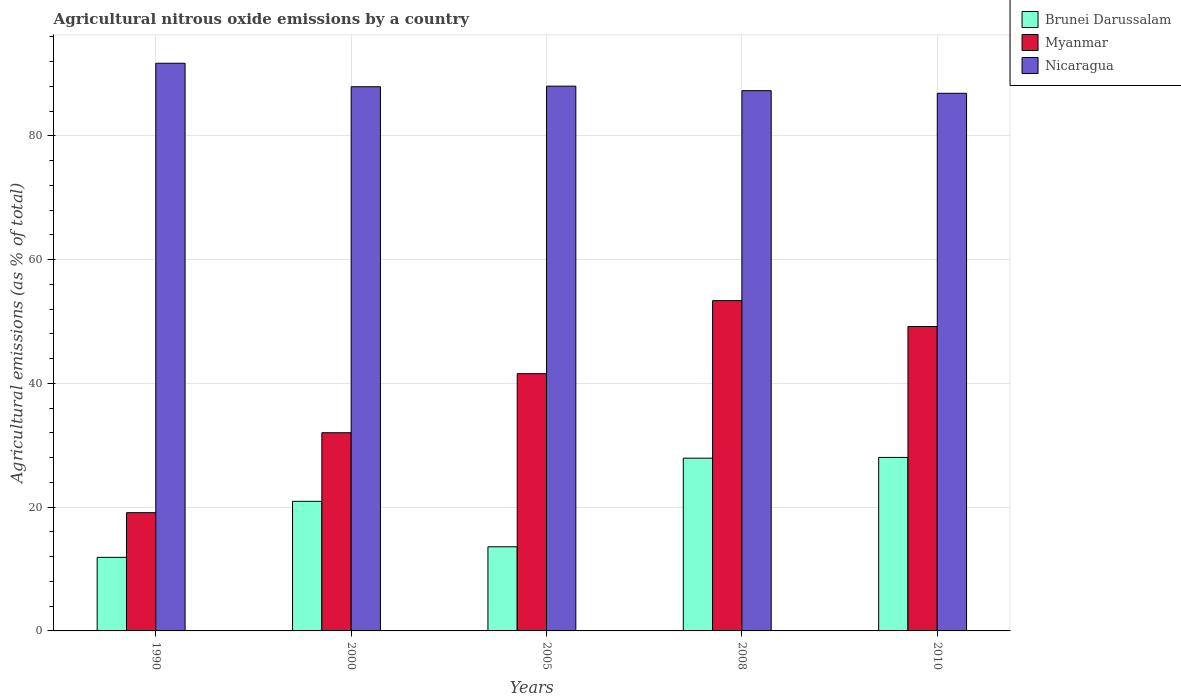Are the number of bars on each tick of the X-axis equal?
Your response must be concise. Yes. How many bars are there on the 5th tick from the left?
Offer a terse response. 3. How many bars are there on the 3rd tick from the right?
Provide a succinct answer. 3. What is the label of the 4th group of bars from the left?
Keep it short and to the point. 2008. In how many cases, is the number of bars for a given year not equal to the number of legend labels?
Offer a terse response. 0. What is the amount of agricultural nitrous oxide emitted in Nicaragua in 2000?
Offer a terse response. 87.95. Across all years, what is the maximum amount of agricultural nitrous oxide emitted in Brunei Darussalam?
Offer a very short reply. 28.04. Across all years, what is the minimum amount of agricultural nitrous oxide emitted in Nicaragua?
Make the answer very short. 86.89. What is the total amount of agricultural nitrous oxide emitted in Brunei Darussalam in the graph?
Offer a very short reply. 102.4. What is the difference between the amount of agricultural nitrous oxide emitted in Nicaragua in 2005 and that in 2010?
Keep it short and to the point. 1.15. What is the difference between the amount of agricultural nitrous oxide emitted in Myanmar in 2008 and the amount of agricultural nitrous oxide emitted in Brunei Darussalam in 2005?
Ensure brevity in your answer.  39.78. What is the average amount of agricultural nitrous oxide emitted in Nicaragua per year?
Keep it short and to the point. 88.39. In the year 2010, what is the difference between the amount of agricultural nitrous oxide emitted in Brunei Darussalam and amount of agricultural nitrous oxide emitted in Nicaragua?
Your response must be concise. -58.85. What is the ratio of the amount of agricultural nitrous oxide emitted in Myanmar in 1990 to that in 2005?
Make the answer very short. 0.46. Is the difference between the amount of agricultural nitrous oxide emitted in Brunei Darussalam in 1990 and 2000 greater than the difference between the amount of agricultural nitrous oxide emitted in Nicaragua in 1990 and 2000?
Make the answer very short. No. What is the difference between the highest and the second highest amount of agricultural nitrous oxide emitted in Brunei Darussalam?
Your answer should be very brief. 0.12. What is the difference between the highest and the lowest amount of agricultural nitrous oxide emitted in Myanmar?
Ensure brevity in your answer.  34.27. In how many years, is the amount of agricultural nitrous oxide emitted in Brunei Darussalam greater than the average amount of agricultural nitrous oxide emitted in Brunei Darussalam taken over all years?
Provide a short and direct response. 3. What does the 1st bar from the left in 2010 represents?
Your response must be concise. Brunei Darussalam. What does the 2nd bar from the right in 1990 represents?
Offer a very short reply. Myanmar. Is it the case that in every year, the sum of the amount of agricultural nitrous oxide emitted in Myanmar and amount of agricultural nitrous oxide emitted in Brunei Darussalam is greater than the amount of agricultural nitrous oxide emitted in Nicaragua?
Ensure brevity in your answer.  No. How many bars are there?
Offer a very short reply. 15. Are all the bars in the graph horizontal?
Provide a short and direct response. No. How many years are there in the graph?
Keep it short and to the point. 5. What is the difference between two consecutive major ticks on the Y-axis?
Give a very brief answer. 20. Where does the legend appear in the graph?
Provide a short and direct response. Top right. What is the title of the graph?
Your response must be concise. Agricultural nitrous oxide emissions by a country. What is the label or title of the Y-axis?
Provide a short and direct response. Agricultural emissions (as % of total). What is the Agricultural emissions (as % of total) in Brunei Darussalam in 1990?
Make the answer very short. 11.89. What is the Agricultural emissions (as % of total) of Myanmar in 1990?
Make the answer very short. 19.11. What is the Agricultural emissions (as % of total) of Nicaragua in 1990?
Provide a succinct answer. 91.75. What is the Agricultural emissions (as % of total) in Brunei Darussalam in 2000?
Provide a succinct answer. 20.95. What is the Agricultural emissions (as % of total) of Myanmar in 2000?
Offer a very short reply. 32.03. What is the Agricultural emissions (as % of total) of Nicaragua in 2000?
Provide a short and direct response. 87.95. What is the Agricultural emissions (as % of total) of Brunei Darussalam in 2005?
Make the answer very short. 13.6. What is the Agricultural emissions (as % of total) of Myanmar in 2005?
Your answer should be compact. 41.58. What is the Agricultural emissions (as % of total) of Nicaragua in 2005?
Your response must be concise. 88.05. What is the Agricultural emissions (as % of total) in Brunei Darussalam in 2008?
Your answer should be very brief. 27.92. What is the Agricultural emissions (as % of total) of Myanmar in 2008?
Make the answer very short. 53.38. What is the Agricultural emissions (as % of total) of Nicaragua in 2008?
Your answer should be very brief. 87.32. What is the Agricultural emissions (as % of total) in Brunei Darussalam in 2010?
Ensure brevity in your answer.  28.04. What is the Agricultural emissions (as % of total) of Myanmar in 2010?
Your answer should be very brief. 49.2. What is the Agricultural emissions (as % of total) in Nicaragua in 2010?
Keep it short and to the point. 86.89. Across all years, what is the maximum Agricultural emissions (as % of total) in Brunei Darussalam?
Offer a very short reply. 28.04. Across all years, what is the maximum Agricultural emissions (as % of total) of Myanmar?
Keep it short and to the point. 53.38. Across all years, what is the maximum Agricultural emissions (as % of total) of Nicaragua?
Make the answer very short. 91.75. Across all years, what is the minimum Agricultural emissions (as % of total) of Brunei Darussalam?
Offer a very short reply. 11.89. Across all years, what is the minimum Agricultural emissions (as % of total) in Myanmar?
Offer a very short reply. 19.11. Across all years, what is the minimum Agricultural emissions (as % of total) of Nicaragua?
Give a very brief answer. 86.89. What is the total Agricultural emissions (as % of total) of Brunei Darussalam in the graph?
Give a very brief answer. 102.4. What is the total Agricultural emissions (as % of total) in Myanmar in the graph?
Your answer should be compact. 195.3. What is the total Agricultural emissions (as % of total) in Nicaragua in the graph?
Offer a terse response. 441.96. What is the difference between the Agricultural emissions (as % of total) of Brunei Darussalam in 1990 and that in 2000?
Give a very brief answer. -9.06. What is the difference between the Agricultural emissions (as % of total) in Myanmar in 1990 and that in 2000?
Ensure brevity in your answer.  -12.92. What is the difference between the Agricultural emissions (as % of total) in Nicaragua in 1990 and that in 2000?
Provide a succinct answer. 3.79. What is the difference between the Agricultural emissions (as % of total) of Brunei Darussalam in 1990 and that in 2005?
Offer a very short reply. -1.71. What is the difference between the Agricultural emissions (as % of total) in Myanmar in 1990 and that in 2005?
Your response must be concise. -22.47. What is the difference between the Agricultural emissions (as % of total) in Nicaragua in 1990 and that in 2005?
Give a very brief answer. 3.7. What is the difference between the Agricultural emissions (as % of total) in Brunei Darussalam in 1990 and that in 2008?
Give a very brief answer. -16.03. What is the difference between the Agricultural emissions (as % of total) in Myanmar in 1990 and that in 2008?
Offer a terse response. -34.27. What is the difference between the Agricultural emissions (as % of total) in Nicaragua in 1990 and that in 2008?
Provide a short and direct response. 4.43. What is the difference between the Agricultural emissions (as % of total) in Brunei Darussalam in 1990 and that in 2010?
Make the answer very short. -16.15. What is the difference between the Agricultural emissions (as % of total) in Myanmar in 1990 and that in 2010?
Make the answer very short. -30.09. What is the difference between the Agricultural emissions (as % of total) of Nicaragua in 1990 and that in 2010?
Offer a terse response. 4.85. What is the difference between the Agricultural emissions (as % of total) of Brunei Darussalam in 2000 and that in 2005?
Ensure brevity in your answer.  7.35. What is the difference between the Agricultural emissions (as % of total) of Myanmar in 2000 and that in 2005?
Offer a very short reply. -9.54. What is the difference between the Agricultural emissions (as % of total) in Nicaragua in 2000 and that in 2005?
Offer a terse response. -0.09. What is the difference between the Agricultural emissions (as % of total) in Brunei Darussalam in 2000 and that in 2008?
Provide a short and direct response. -6.97. What is the difference between the Agricultural emissions (as % of total) of Myanmar in 2000 and that in 2008?
Keep it short and to the point. -21.35. What is the difference between the Agricultural emissions (as % of total) of Nicaragua in 2000 and that in 2008?
Provide a succinct answer. 0.64. What is the difference between the Agricultural emissions (as % of total) of Brunei Darussalam in 2000 and that in 2010?
Ensure brevity in your answer.  -7.09. What is the difference between the Agricultural emissions (as % of total) of Myanmar in 2000 and that in 2010?
Keep it short and to the point. -17.17. What is the difference between the Agricultural emissions (as % of total) of Nicaragua in 2000 and that in 2010?
Your answer should be compact. 1.06. What is the difference between the Agricultural emissions (as % of total) of Brunei Darussalam in 2005 and that in 2008?
Ensure brevity in your answer.  -14.32. What is the difference between the Agricultural emissions (as % of total) in Myanmar in 2005 and that in 2008?
Your answer should be very brief. -11.81. What is the difference between the Agricultural emissions (as % of total) of Nicaragua in 2005 and that in 2008?
Your answer should be compact. 0.73. What is the difference between the Agricultural emissions (as % of total) in Brunei Darussalam in 2005 and that in 2010?
Your answer should be very brief. -14.44. What is the difference between the Agricultural emissions (as % of total) in Myanmar in 2005 and that in 2010?
Your answer should be compact. -7.62. What is the difference between the Agricultural emissions (as % of total) of Nicaragua in 2005 and that in 2010?
Provide a short and direct response. 1.15. What is the difference between the Agricultural emissions (as % of total) of Brunei Darussalam in 2008 and that in 2010?
Offer a terse response. -0.12. What is the difference between the Agricultural emissions (as % of total) in Myanmar in 2008 and that in 2010?
Your response must be concise. 4.18. What is the difference between the Agricultural emissions (as % of total) in Nicaragua in 2008 and that in 2010?
Provide a succinct answer. 0.42. What is the difference between the Agricultural emissions (as % of total) in Brunei Darussalam in 1990 and the Agricultural emissions (as % of total) in Myanmar in 2000?
Give a very brief answer. -20.14. What is the difference between the Agricultural emissions (as % of total) of Brunei Darussalam in 1990 and the Agricultural emissions (as % of total) of Nicaragua in 2000?
Your answer should be very brief. -76.07. What is the difference between the Agricultural emissions (as % of total) of Myanmar in 1990 and the Agricultural emissions (as % of total) of Nicaragua in 2000?
Offer a very short reply. -68.84. What is the difference between the Agricultural emissions (as % of total) in Brunei Darussalam in 1990 and the Agricultural emissions (as % of total) in Myanmar in 2005?
Make the answer very short. -29.69. What is the difference between the Agricultural emissions (as % of total) of Brunei Darussalam in 1990 and the Agricultural emissions (as % of total) of Nicaragua in 2005?
Offer a terse response. -76.16. What is the difference between the Agricultural emissions (as % of total) of Myanmar in 1990 and the Agricultural emissions (as % of total) of Nicaragua in 2005?
Keep it short and to the point. -68.94. What is the difference between the Agricultural emissions (as % of total) in Brunei Darussalam in 1990 and the Agricultural emissions (as % of total) in Myanmar in 2008?
Your answer should be very brief. -41.49. What is the difference between the Agricultural emissions (as % of total) in Brunei Darussalam in 1990 and the Agricultural emissions (as % of total) in Nicaragua in 2008?
Your answer should be compact. -75.43. What is the difference between the Agricultural emissions (as % of total) of Myanmar in 1990 and the Agricultural emissions (as % of total) of Nicaragua in 2008?
Make the answer very short. -68.21. What is the difference between the Agricultural emissions (as % of total) in Brunei Darussalam in 1990 and the Agricultural emissions (as % of total) in Myanmar in 2010?
Keep it short and to the point. -37.31. What is the difference between the Agricultural emissions (as % of total) of Brunei Darussalam in 1990 and the Agricultural emissions (as % of total) of Nicaragua in 2010?
Your answer should be very brief. -75. What is the difference between the Agricultural emissions (as % of total) of Myanmar in 1990 and the Agricultural emissions (as % of total) of Nicaragua in 2010?
Ensure brevity in your answer.  -67.78. What is the difference between the Agricultural emissions (as % of total) of Brunei Darussalam in 2000 and the Agricultural emissions (as % of total) of Myanmar in 2005?
Your answer should be compact. -20.63. What is the difference between the Agricultural emissions (as % of total) in Brunei Darussalam in 2000 and the Agricultural emissions (as % of total) in Nicaragua in 2005?
Provide a succinct answer. -67.1. What is the difference between the Agricultural emissions (as % of total) of Myanmar in 2000 and the Agricultural emissions (as % of total) of Nicaragua in 2005?
Make the answer very short. -56.01. What is the difference between the Agricultural emissions (as % of total) of Brunei Darussalam in 2000 and the Agricultural emissions (as % of total) of Myanmar in 2008?
Make the answer very short. -32.44. What is the difference between the Agricultural emissions (as % of total) of Brunei Darussalam in 2000 and the Agricultural emissions (as % of total) of Nicaragua in 2008?
Offer a very short reply. -66.37. What is the difference between the Agricultural emissions (as % of total) in Myanmar in 2000 and the Agricultural emissions (as % of total) in Nicaragua in 2008?
Give a very brief answer. -55.28. What is the difference between the Agricultural emissions (as % of total) in Brunei Darussalam in 2000 and the Agricultural emissions (as % of total) in Myanmar in 2010?
Offer a very short reply. -28.25. What is the difference between the Agricultural emissions (as % of total) in Brunei Darussalam in 2000 and the Agricultural emissions (as % of total) in Nicaragua in 2010?
Make the answer very short. -65.95. What is the difference between the Agricultural emissions (as % of total) in Myanmar in 2000 and the Agricultural emissions (as % of total) in Nicaragua in 2010?
Offer a terse response. -54.86. What is the difference between the Agricultural emissions (as % of total) of Brunei Darussalam in 2005 and the Agricultural emissions (as % of total) of Myanmar in 2008?
Offer a very short reply. -39.78. What is the difference between the Agricultural emissions (as % of total) in Brunei Darussalam in 2005 and the Agricultural emissions (as % of total) in Nicaragua in 2008?
Make the answer very short. -73.72. What is the difference between the Agricultural emissions (as % of total) of Myanmar in 2005 and the Agricultural emissions (as % of total) of Nicaragua in 2008?
Keep it short and to the point. -45.74. What is the difference between the Agricultural emissions (as % of total) of Brunei Darussalam in 2005 and the Agricultural emissions (as % of total) of Myanmar in 2010?
Keep it short and to the point. -35.6. What is the difference between the Agricultural emissions (as % of total) in Brunei Darussalam in 2005 and the Agricultural emissions (as % of total) in Nicaragua in 2010?
Keep it short and to the point. -73.29. What is the difference between the Agricultural emissions (as % of total) in Myanmar in 2005 and the Agricultural emissions (as % of total) in Nicaragua in 2010?
Make the answer very short. -45.32. What is the difference between the Agricultural emissions (as % of total) of Brunei Darussalam in 2008 and the Agricultural emissions (as % of total) of Myanmar in 2010?
Your response must be concise. -21.28. What is the difference between the Agricultural emissions (as % of total) in Brunei Darussalam in 2008 and the Agricultural emissions (as % of total) in Nicaragua in 2010?
Your answer should be compact. -58.97. What is the difference between the Agricultural emissions (as % of total) of Myanmar in 2008 and the Agricultural emissions (as % of total) of Nicaragua in 2010?
Provide a short and direct response. -33.51. What is the average Agricultural emissions (as % of total) in Brunei Darussalam per year?
Offer a terse response. 20.48. What is the average Agricultural emissions (as % of total) of Myanmar per year?
Give a very brief answer. 39.06. What is the average Agricultural emissions (as % of total) in Nicaragua per year?
Give a very brief answer. 88.39. In the year 1990, what is the difference between the Agricultural emissions (as % of total) in Brunei Darussalam and Agricultural emissions (as % of total) in Myanmar?
Make the answer very short. -7.22. In the year 1990, what is the difference between the Agricultural emissions (as % of total) in Brunei Darussalam and Agricultural emissions (as % of total) in Nicaragua?
Provide a succinct answer. -79.86. In the year 1990, what is the difference between the Agricultural emissions (as % of total) in Myanmar and Agricultural emissions (as % of total) in Nicaragua?
Offer a terse response. -72.64. In the year 2000, what is the difference between the Agricultural emissions (as % of total) in Brunei Darussalam and Agricultural emissions (as % of total) in Myanmar?
Ensure brevity in your answer.  -11.09. In the year 2000, what is the difference between the Agricultural emissions (as % of total) of Brunei Darussalam and Agricultural emissions (as % of total) of Nicaragua?
Give a very brief answer. -67.01. In the year 2000, what is the difference between the Agricultural emissions (as % of total) of Myanmar and Agricultural emissions (as % of total) of Nicaragua?
Offer a terse response. -55.92. In the year 2005, what is the difference between the Agricultural emissions (as % of total) of Brunei Darussalam and Agricultural emissions (as % of total) of Myanmar?
Keep it short and to the point. -27.98. In the year 2005, what is the difference between the Agricultural emissions (as % of total) in Brunei Darussalam and Agricultural emissions (as % of total) in Nicaragua?
Your answer should be very brief. -74.45. In the year 2005, what is the difference between the Agricultural emissions (as % of total) in Myanmar and Agricultural emissions (as % of total) in Nicaragua?
Keep it short and to the point. -46.47. In the year 2008, what is the difference between the Agricultural emissions (as % of total) of Brunei Darussalam and Agricultural emissions (as % of total) of Myanmar?
Offer a very short reply. -25.46. In the year 2008, what is the difference between the Agricultural emissions (as % of total) in Brunei Darussalam and Agricultural emissions (as % of total) in Nicaragua?
Provide a short and direct response. -59.39. In the year 2008, what is the difference between the Agricultural emissions (as % of total) in Myanmar and Agricultural emissions (as % of total) in Nicaragua?
Your answer should be compact. -33.93. In the year 2010, what is the difference between the Agricultural emissions (as % of total) in Brunei Darussalam and Agricultural emissions (as % of total) in Myanmar?
Provide a short and direct response. -21.16. In the year 2010, what is the difference between the Agricultural emissions (as % of total) in Brunei Darussalam and Agricultural emissions (as % of total) in Nicaragua?
Give a very brief answer. -58.85. In the year 2010, what is the difference between the Agricultural emissions (as % of total) of Myanmar and Agricultural emissions (as % of total) of Nicaragua?
Offer a terse response. -37.69. What is the ratio of the Agricultural emissions (as % of total) of Brunei Darussalam in 1990 to that in 2000?
Your answer should be compact. 0.57. What is the ratio of the Agricultural emissions (as % of total) in Myanmar in 1990 to that in 2000?
Offer a very short reply. 0.6. What is the ratio of the Agricultural emissions (as % of total) of Nicaragua in 1990 to that in 2000?
Offer a very short reply. 1.04. What is the ratio of the Agricultural emissions (as % of total) in Brunei Darussalam in 1990 to that in 2005?
Your response must be concise. 0.87. What is the ratio of the Agricultural emissions (as % of total) in Myanmar in 1990 to that in 2005?
Provide a succinct answer. 0.46. What is the ratio of the Agricultural emissions (as % of total) in Nicaragua in 1990 to that in 2005?
Ensure brevity in your answer.  1.04. What is the ratio of the Agricultural emissions (as % of total) of Brunei Darussalam in 1990 to that in 2008?
Provide a short and direct response. 0.43. What is the ratio of the Agricultural emissions (as % of total) in Myanmar in 1990 to that in 2008?
Your answer should be very brief. 0.36. What is the ratio of the Agricultural emissions (as % of total) in Nicaragua in 1990 to that in 2008?
Your response must be concise. 1.05. What is the ratio of the Agricultural emissions (as % of total) of Brunei Darussalam in 1990 to that in 2010?
Provide a short and direct response. 0.42. What is the ratio of the Agricultural emissions (as % of total) in Myanmar in 1990 to that in 2010?
Your answer should be compact. 0.39. What is the ratio of the Agricultural emissions (as % of total) in Nicaragua in 1990 to that in 2010?
Provide a succinct answer. 1.06. What is the ratio of the Agricultural emissions (as % of total) of Brunei Darussalam in 2000 to that in 2005?
Offer a very short reply. 1.54. What is the ratio of the Agricultural emissions (as % of total) in Myanmar in 2000 to that in 2005?
Make the answer very short. 0.77. What is the ratio of the Agricultural emissions (as % of total) of Brunei Darussalam in 2000 to that in 2008?
Provide a short and direct response. 0.75. What is the ratio of the Agricultural emissions (as % of total) of Myanmar in 2000 to that in 2008?
Provide a succinct answer. 0.6. What is the ratio of the Agricultural emissions (as % of total) in Nicaragua in 2000 to that in 2008?
Ensure brevity in your answer.  1.01. What is the ratio of the Agricultural emissions (as % of total) of Brunei Darussalam in 2000 to that in 2010?
Give a very brief answer. 0.75. What is the ratio of the Agricultural emissions (as % of total) of Myanmar in 2000 to that in 2010?
Give a very brief answer. 0.65. What is the ratio of the Agricultural emissions (as % of total) of Nicaragua in 2000 to that in 2010?
Keep it short and to the point. 1.01. What is the ratio of the Agricultural emissions (as % of total) of Brunei Darussalam in 2005 to that in 2008?
Give a very brief answer. 0.49. What is the ratio of the Agricultural emissions (as % of total) in Myanmar in 2005 to that in 2008?
Offer a very short reply. 0.78. What is the ratio of the Agricultural emissions (as % of total) of Nicaragua in 2005 to that in 2008?
Provide a short and direct response. 1.01. What is the ratio of the Agricultural emissions (as % of total) of Brunei Darussalam in 2005 to that in 2010?
Ensure brevity in your answer.  0.48. What is the ratio of the Agricultural emissions (as % of total) of Myanmar in 2005 to that in 2010?
Provide a succinct answer. 0.85. What is the ratio of the Agricultural emissions (as % of total) of Nicaragua in 2005 to that in 2010?
Your answer should be compact. 1.01. What is the ratio of the Agricultural emissions (as % of total) in Brunei Darussalam in 2008 to that in 2010?
Make the answer very short. 1. What is the ratio of the Agricultural emissions (as % of total) of Myanmar in 2008 to that in 2010?
Offer a terse response. 1.08. What is the ratio of the Agricultural emissions (as % of total) in Nicaragua in 2008 to that in 2010?
Make the answer very short. 1. What is the difference between the highest and the second highest Agricultural emissions (as % of total) in Brunei Darussalam?
Provide a succinct answer. 0.12. What is the difference between the highest and the second highest Agricultural emissions (as % of total) in Myanmar?
Give a very brief answer. 4.18. What is the difference between the highest and the second highest Agricultural emissions (as % of total) in Nicaragua?
Your response must be concise. 3.7. What is the difference between the highest and the lowest Agricultural emissions (as % of total) of Brunei Darussalam?
Give a very brief answer. 16.15. What is the difference between the highest and the lowest Agricultural emissions (as % of total) of Myanmar?
Offer a terse response. 34.27. What is the difference between the highest and the lowest Agricultural emissions (as % of total) in Nicaragua?
Your response must be concise. 4.85. 